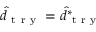<formula> <loc_0><loc_0><loc_500><loc_500>\hat { d } _ { t r y } = \hat { d } _ { t r y } ^ { * }</formula> 